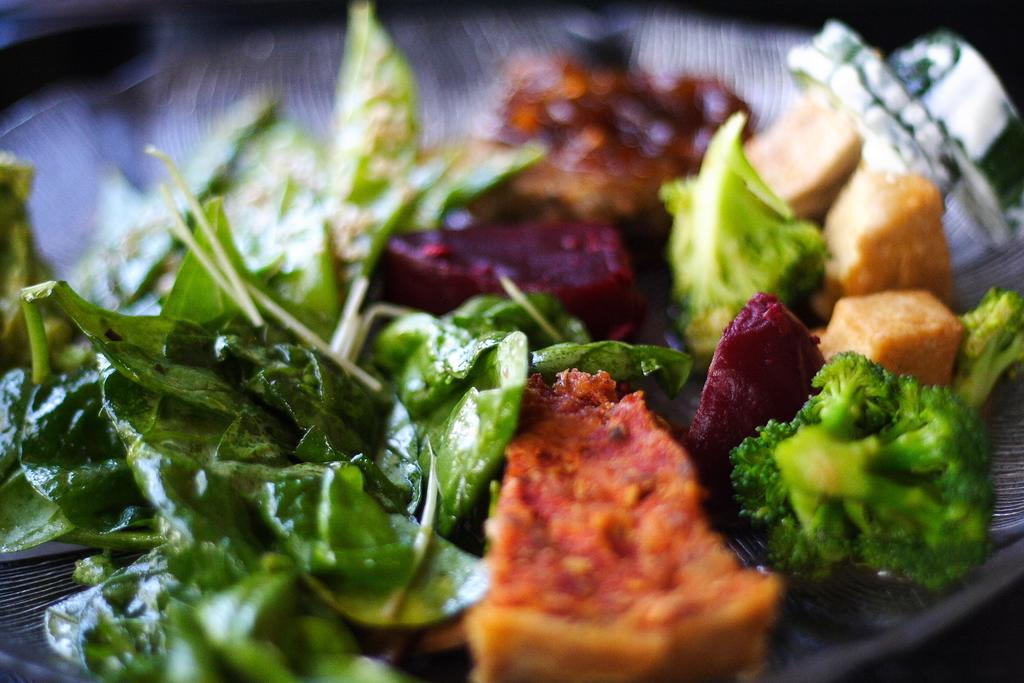What type of vegetation is present in the image? There are vegetable leaves in the image. What is on the plate that is visible in the image? There is food on a plate in the image. Can you describe the background of the image? The background of the image is blurry. What type of guitar is the doctor playing in the image? There is no guitar or doctor present in the image. What room is the image taken in? The provided facts do not specify the room or location where the image was taken. 